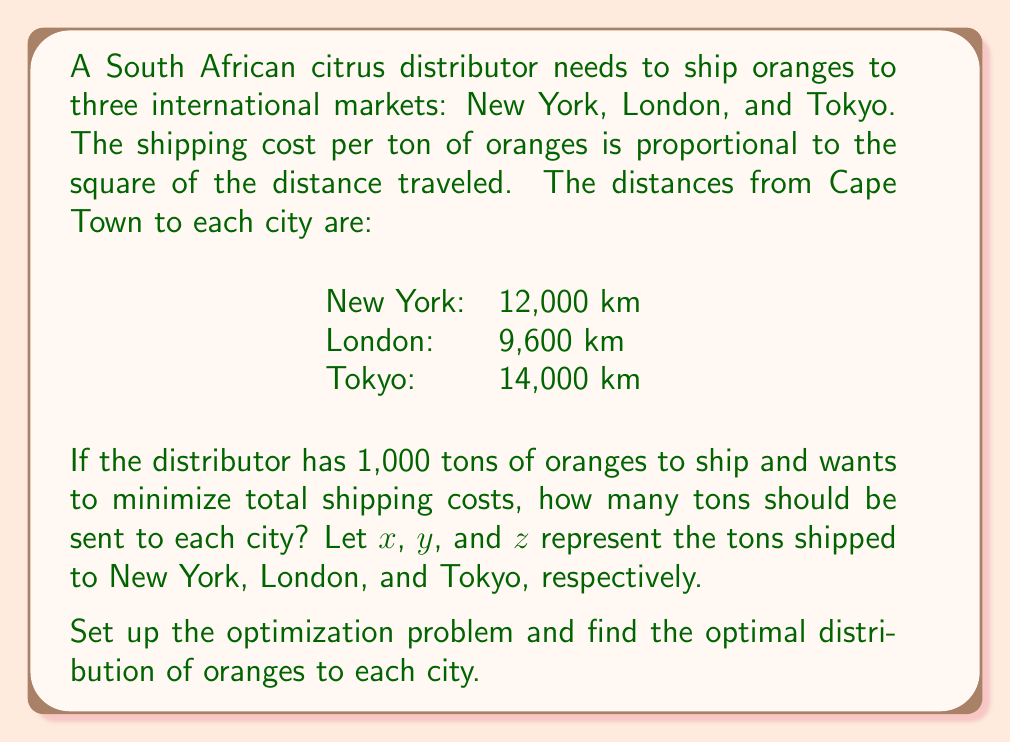Provide a solution to this math problem. Let's approach this step-by-step:

1) First, we need to set up the objective function to minimize. Since the cost is proportional to the square of the distance, we can write:

   Minimize: $f(x,y,z) = 12000^2x + 9600^2y + 14000^2z$

2) We have two constraints:
   a) The total amount shipped must equal 1,000 tons: $x + y + z = 1000$
   b) Non-negativity: $x, y, z \geq 0$

3) To solve this, we can use the method of Lagrange multipliers. Let's form the Lagrangian:

   $L(x,y,z,\lambda) = 12000^2x + 9600^2y + 14000^2z + \lambda(x + y + z - 1000)$

4) Now, we take partial derivatives and set them equal to zero:

   $\frac{\partial L}{\partial x} = 144,000,000 + \lambda = 0$
   $\frac{\partial L}{\partial y} = 92,160,000 + \lambda = 0$
   $\frac{\partial L}{\partial z} = 196,000,000 + \lambda = 0$
   $\frac{\partial L}{\partial \lambda} = x + y + z - 1000 = 0$

5) From the first three equations, we can see that:

   $144,000,000 + \lambda = 92,160,000 + \lambda = 196,000,000 + \lambda$

   This implies:

   $\frac{x}{12000^2} = \frac{y}{9600^2} = \frac{z}{14000^2}$

6) Let's call this common ratio $k$. Then:

   $x = 144,000,000k$
   $y = 92,160,000k$
   $z = 196,000,000k$

7) Substituting these into our constraint equation:

   $144,000,000k + 92,160,000k + 196,000,000k = 1000$
   $432,160,000k = 1000$
   $k = \frac{1000}{432,160,000} = \frac{5}{2160800}$

8) Now we can solve for $x$, $y$, and $z$:

   $x = 144,000,000 \cdot \frac{5}{2160800} \approx 333.33$
   $y = 92,160,000 \cdot \frac{5}{2160800} \approx 213.33$
   $z = 196,000,000 \cdot \frac{5}{2160800} \approx 453.33$
Answer: New York: 333.33 tons, London: 213.33 tons, Tokyo: 453.33 tons 